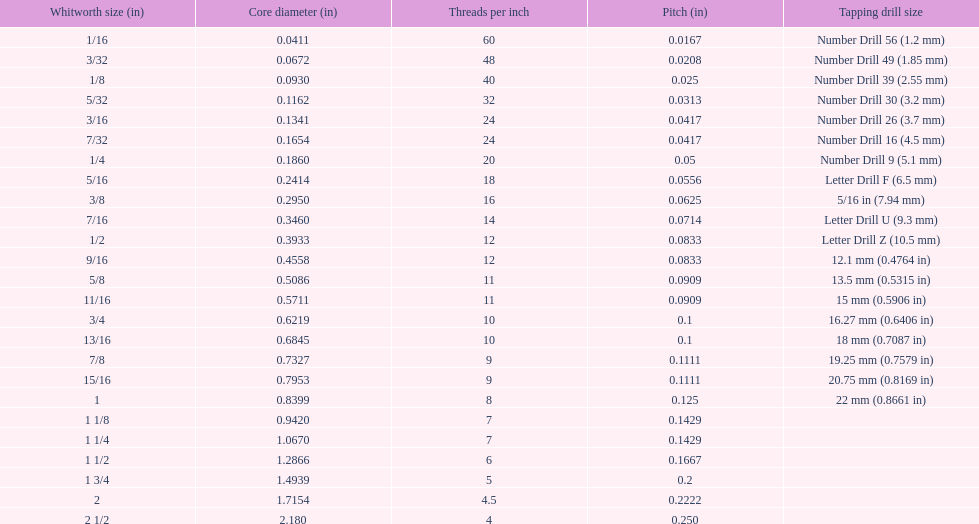Write the full table. {'header': ['Whitworth size (in)', 'Core diameter (in)', 'Threads per\xa0inch', 'Pitch (in)', 'Tapping drill size'], 'rows': [['1/16', '0.0411', '60', '0.0167', 'Number Drill 56 (1.2\xa0mm)'], ['3/32', '0.0672', '48', '0.0208', 'Number Drill 49 (1.85\xa0mm)'], ['1/8', '0.0930', '40', '0.025', 'Number Drill 39 (2.55\xa0mm)'], ['5/32', '0.1162', '32', '0.0313', 'Number Drill 30 (3.2\xa0mm)'], ['3/16', '0.1341', '24', '0.0417', 'Number Drill 26 (3.7\xa0mm)'], ['7/32', '0.1654', '24', '0.0417', 'Number Drill 16 (4.5\xa0mm)'], ['1/4', '0.1860', '20', '0.05', 'Number Drill 9 (5.1\xa0mm)'], ['5/16', '0.2414', '18', '0.0556', 'Letter Drill F (6.5\xa0mm)'], ['3/8', '0.2950', '16', '0.0625', '5/16\xa0in (7.94\xa0mm)'], ['7/16', '0.3460', '14', '0.0714', 'Letter Drill U (9.3\xa0mm)'], ['1/2', '0.3933', '12', '0.0833', 'Letter Drill Z (10.5\xa0mm)'], ['9/16', '0.4558', '12', '0.0833', '12.1\xa0mm (0.4764\xa0in)'], ['5/8', '0.5086', '11', '0.0909', '13.5\xa0mm (0.5315\xa0in)'], ['11/16', '0.5711', '11', '0.0909', '15\xa0mm (0.5906\xa0in)'], ['3/4', '0.6219', '10', '0.1', '16.27\xa0mm (0.6406\xa0in)'], ['13/16', '0.6845', '10', '0.1', '18\xa0mm (0.7087\xa0in)'], ['7/8', '0.7327', '9', '0.1111', '19.25\xa0mm (0.7579\xa0in)'], ['15/16', '0.7953', '9', '0.1111', '20.75\xa0mm (0.8169\xa0in)'], ['1', '0.8399', '8', '0.125', '22\xa0mm (0.8661\xa0in)'], ['1 1/8', '0.9420', '7', '0.1429', ''], ['1 1/4', '1.0670', '7', '0.1429', ''], ['1 1/2', '1.2866', '6', '0.1667', ''], ['1 3/4', '1.4939', '5', '0.2', ''], ['2', '1.7154', '4.5', '0.2222', ''], ['2 1/2', '2.180', '4', '0.250', '']]} What is the main diameter of the last size in whitworth threads? 2.180. 